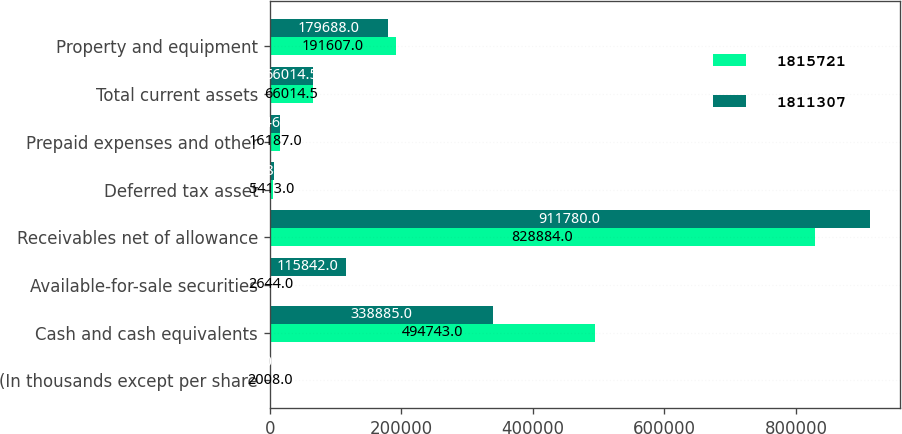Convert chart to OTSL. <chart><loc_0><loc_0><loc_500><loc_500><stacked_bar_chart><ecel><fcel>(In thousands except per share<fcel>Cash and cash equivalents<fcel>Available-for-sale securities<fcel>Receivables net of allowance<fcel>Deferred tax asset<fcel>Prepaid expenses and other<fcel>Total current assets<fcel>Property and equipment<nl><fcel>1.81572e+06<fcel>2008<fcel>494743<fcel>2644<fcel>828884<fcel>5413<fcel>16187<fcel>66014.5<fcel>191607<nl><fcel>1.81131e+06<fcel>2007<fcel>338885<fcel>115842<fcel>911780<fcel>7184<fcel>15465<fcel>66014.5<fcel>179688<nl></chart> 